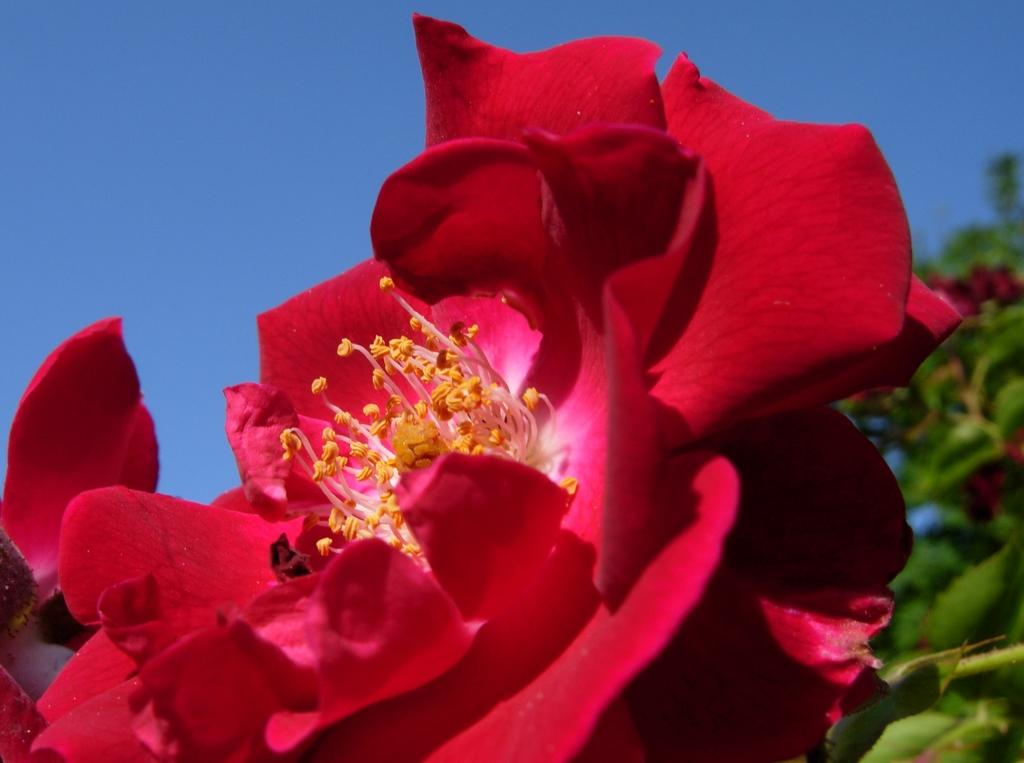What type of plants can be seen in the image? There are flowers and leaves in the image. What can be seen in the background of the image? The sky is visible in the background of the image. What type of rabbit can be seen playing with the farmer in the image? There is no rabbit or farmer present in the image; it only features flowers, leaves, and the sky. 